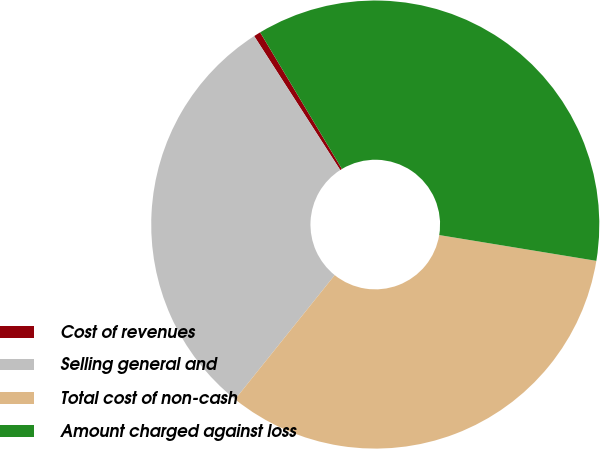Convert chart to OTSL. <chart><loc_0><loc_0><loc_500><loc_500><pie_chart><fcel>Cost of revenues<fcel>Selling general and<fcel>Total cost of non-cash<fcel>Amount charged against loss<nl><fcel>0.5%<fcel>30.15%<fcel>33.17%<fcel>36.18%<nl></chart> 